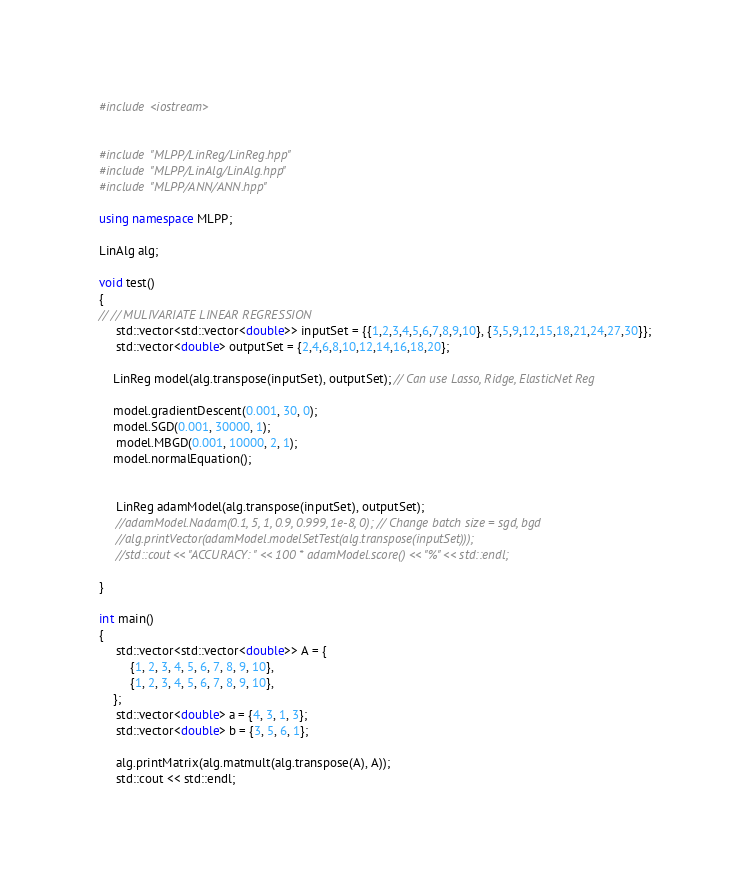<code> <loc_0><loc_0><loc_500><loc_500><_C++_>#include <iostream>


#include "MLPP/LinReg/LinReg.hpp"
#include "MLPP/LinAlg/LinAlg.hpp"
#include "MLPP/ANN/ANN.hpp"

using namespace MLPP;

LinAlg alg;

void test()
{
// // MULIVARIATE LINEAR REGRESSION
     std::vector<std::vector<double>> inputSet = {{1,2,3,4,5,6,7,8,9,10}, {3,5,9,12,15,18,21,24,27,30}};
     std::vector<double> outputSet = {2,4,6,8,10,12,14,16,18,20};

    LinReg model(alg.transpose(inputSet), outputSet); // Can use Lasso, Ridge, ElasticNet Reg

    model.gradientDescent(0.001, 30, 0);
    model.SGD(0.001, 30000, 1);
     model.MBGD(0.001, 10000, 2, 1);
    model.normalEquation(); 


     LinReg adamModel(alg.transpose(inputSet), outputSet);
     //adamModel.Nadam(0.1, 5, 1, 0.9, 0.999, 1e-8, 0); // Change batch size = sgd, bgd
     //alg.printVector(adamModel.modelSetTest(alg.transpose(inputSet)));
     //std::cout << "ACCURACY: " << 100 * adamModel.score() << "%" << std::endl;

}

int main()
{
     std::vector<std::vector<double>> A = {
         {1, 2, 3, 4, 5, 6, 7, 8, 9, 10},
         {1, 2, 3, 4, 5, 6, 7, 8, 9, 10},
    };
     std::vector<double> a = {4, 3, 1, 3};
     std::vector<double> b = {3, 5, 6, 1};

     alg.printMatrix(alg.matmult(alg.transpose(A), A));
     std::cout << std::endl;</code> 